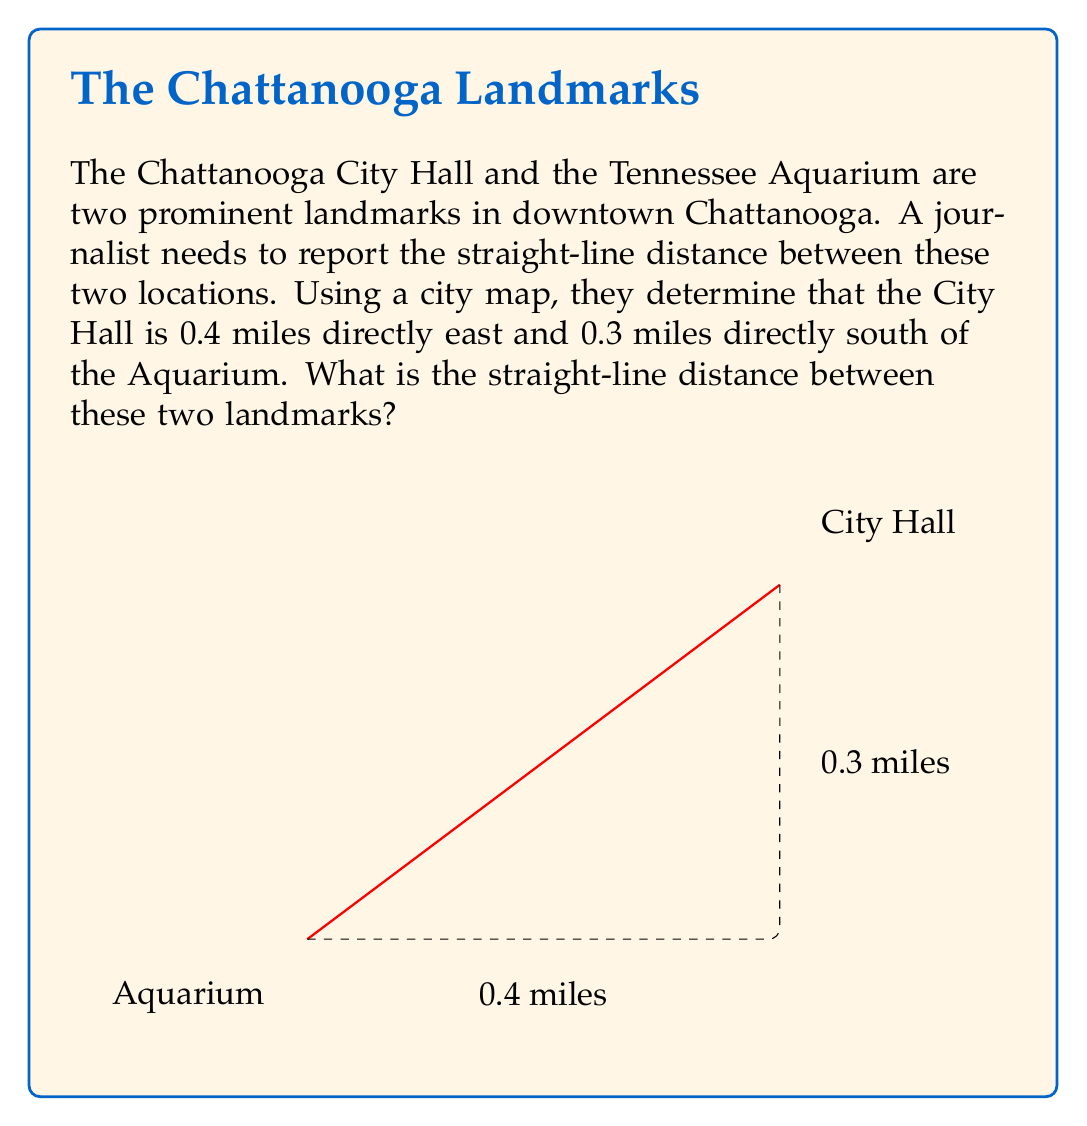Help me with this question. Let's approach this step-by-step using the Pythagorean theorem:

1) The situation forms a right triangle, where:
   - The Aquarium is at one corner
   - The City Hall is at the opposite corner
   - The two perpendicular streets form the other sides

2) We know:
   - The east-west distance is 0.4 miles
   - The north-south distance is 0.3 miles

3) Let's define:
   - $a$ = east-west distance = 0.4 miles
   - $b$ = north-south distance = 0.3 miles
   - $c$ = straight-line distance (what we're solving for)

4) The Pythagorean theorem states: $a^2 + b^2 = c^2$

5) Plugging in our values:
   $$(0.4)^2 + (0.3)^2 = c^2$$

6) Simplify:
   $$0.16 + 0.09 = c^2$$
   $$0.25 = c^2$$

7) Take the square root of both sides:
   $$\sqrt{0.25} = c$$

8) Simplify:
   $$0.5 = c$$

Therefore, the straight-line distance between the Chattanooga City Hall and the Tennessee Aquarium is 0.5 miles.
Answer: $0.5$ miles 